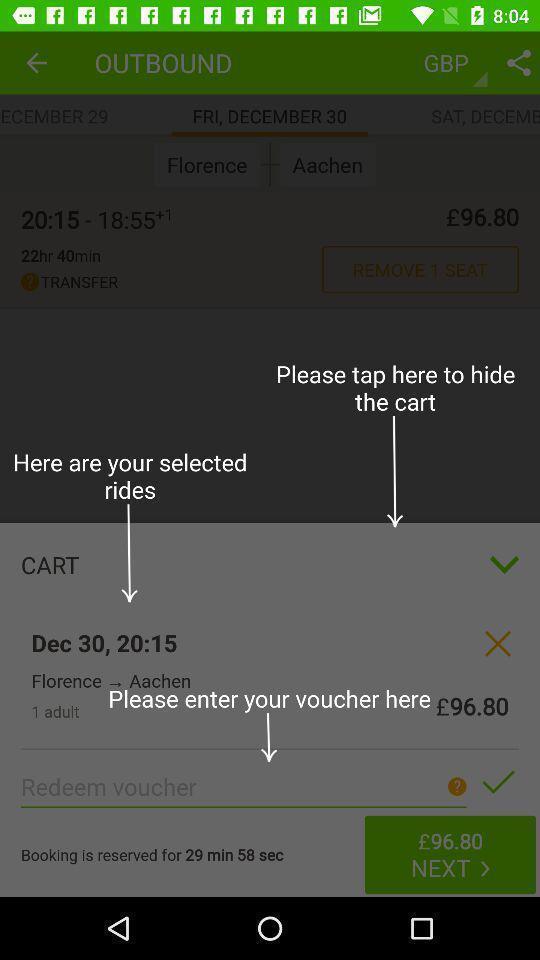Give me a summary of this screen capture. Page of a travel app with price and other details. 